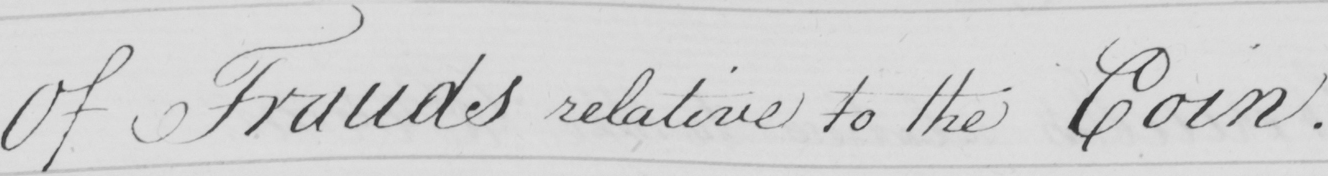Can you read and transcribe this handwriting? Of Frauds relative to the Coin . 